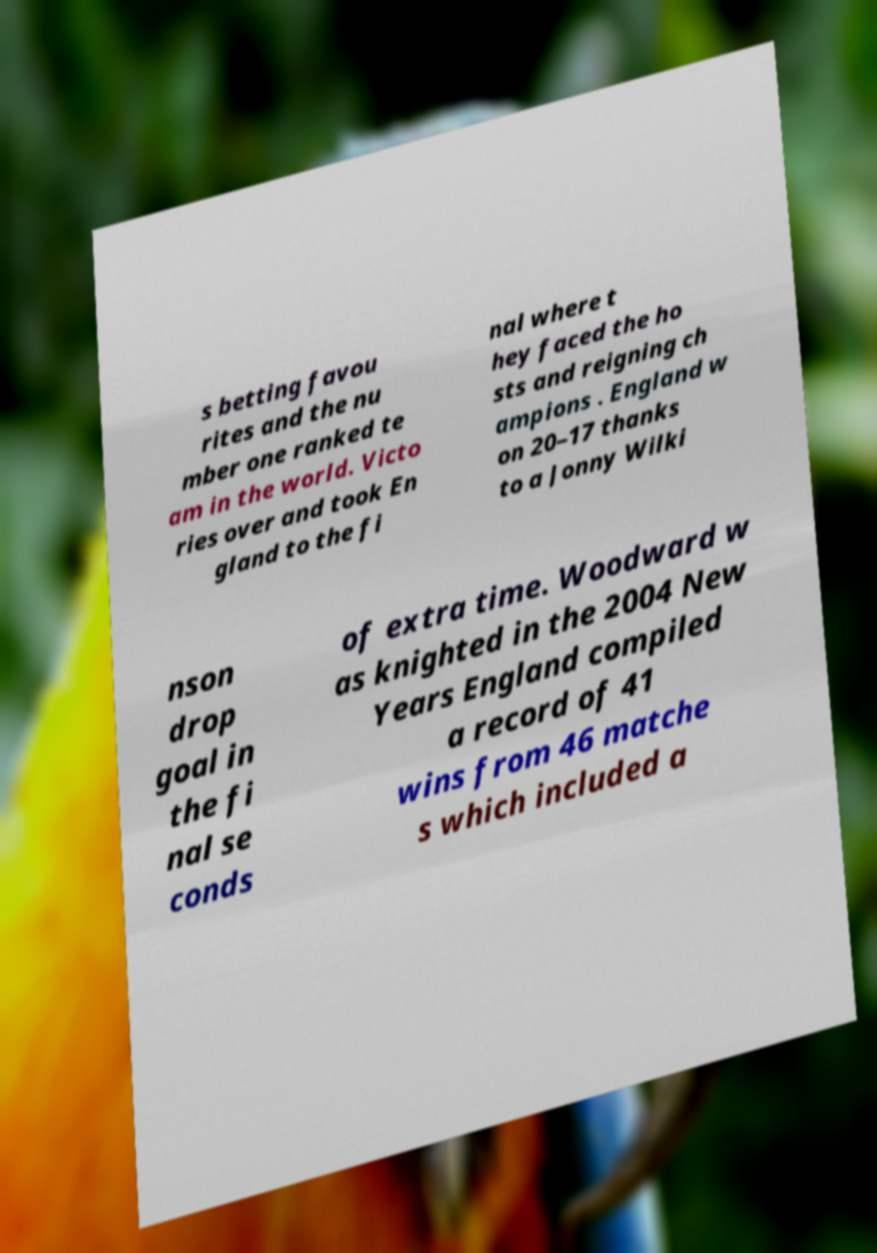Please identify and transcribe the text found in this image. s betting favou rites and the nu mber one ranked te am in the world. Victo ries over and took En gland to the fi nal where t hey faced the ho sts and reigning ch ampions . England w on 20–17 thanks to a Jonny Wilki nson drop goal in the fi nal se conds of extra time. Woodward w as knighted in the 2004 New Years England compiled a record of 41 wins from 46 matche s which included a 